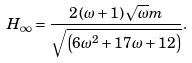<formula> <loc_0><loc_0><loc_500><loc_500>H _ { \infty } = \frac { 2 \left ( \omega + 1 \right ) \sqrt { \omega } m } { \sqrt { \left ( 6 \omega ^ { 2 } + 1 7 \omega + 1 2 \right ) } } .</formula> 